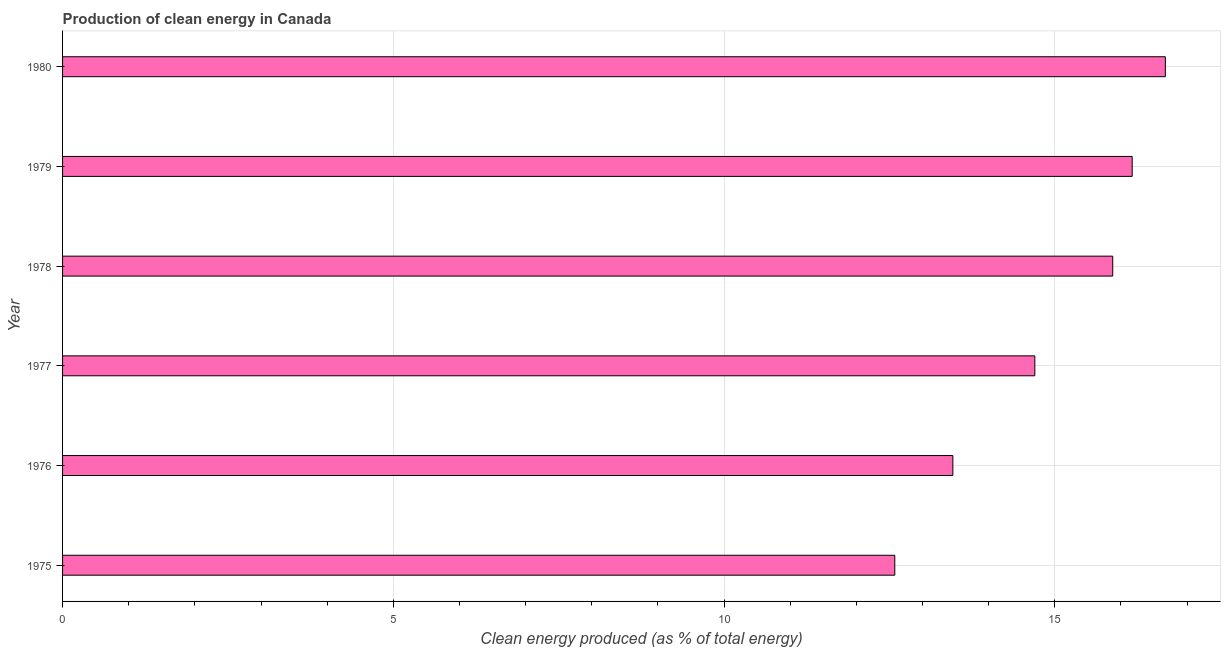Does the graph contain any zero values?
Make the answer very short. No. What is the title of the graph?
Give a very brief answer. Production of clean energy in Canada. What is the label or title of the X-axis?
Keep it short and to the point. Clean energy produced (as % of total energy). What is the production of clean energy in 1975?
Your response must be concise. 12.58. Across all years, what is the maximum production of clean energy?
Keep it short and to the point. 16.67. Across all years, what is the minimum production of clean energy?
Your answer should be compact. 12.58. In which year was the production of clean energy minimum?
Ensure brevity in your answer.  1975. What is the sum of the production of clean energy?
Keep it short and to the point. 89.46. What is the difference between the production of clean energy in 1977 and 1979?
Make the answer very short. -1.47. What is the average production of clean energy per year?
Keep it short and to the point. 14.91. What is the median production of clean energy?
Ensure brevity in your answer.  15.29. Do a majority of the years between 1977 and 1979 (inclusive) have production of clean energy greater than 1 %?
Ensure brevity in your answer.  Yes. What is the ratio of the production of clean energy in 1976 to that in 1980?
Provide a short and direct response. 0.81. Is the production of clean energy in 1975 less than that in 1976?
Offer a terse response. Yes. What is the difference between the highest and the second highest production of clean energy?
Give a very brief answer. 0.5. Is the sum of the production of clean energy in 1975 and 1976 greater than the maximum production of clean energy across all years?
Keep it short and to the point. Yes. What is the difference between the highest and the lowest production of clean energy?
Make the answer very short. 4.09. In how many years, is the production of clean energy greater than the average production of clean energy taken over all years?
Offer a very short reply. 3. How many bars are there?
Make the answer very short. 6. Are all the bars in the graph horizontal?
Give a very brief answer. Yes. How many years are there in the graph?
Your answer should be very brief. 6. What is the difference between two consecutive major ticks on the X-axis?
Give a very brief answer. 5. What is the Clean energy produced (as % of total energy) of 1975?
Offer a terse response. 12.58. What is the Clean energy produced (as % of total energy) of 1976?
Offer a very short reply. 13.46. What is the Clean energy produced (as % of total energy) in 1977?
Give a very brief answer. 14.7. What is the Clean energy produced (as % of total energy) in 1978?
Keep it short and to the point. 15.88. What is the Clean energy produced (as % of total energy) in 1979?
Ensure brevity in your answer.  16.17. What is the Clean energy produced (as % of total energy) of 1980?
Ensure brevity in your answer.  16.67. What is the difference between the Clean energy produced (as % of total energy) in 1975 and 1976?
Provide a short and direct response. -0.88. What is the difference between the Clean energy produced (as % of total energy) in 1975 and 1977?
Ensure brevity in your answer.  -2.12. What is the difference between the Clean energy produced (as % of total energy) in 1975 and 1978?
Your response must be concise. -3.29. What is the difference between the Clean energy produced (as % of total energy) in 1975 and 1979?
Give a very brief answer. -3.59. What is the difference between the Clean energy produced (as % of total energy) in 1975 and 1980?
Keep it short and to the point. -4.09. What is the difference between the Clean energy produced (as % of total energy) in 1976 and 1977?
Your answer should be very brief. -1.24. What is the difference between the Clean energy produced (as % of total energy) in 1976 and 1978?
Provide a short and direct response. -2.42. What is the difference between the Clean energy produced (as % of total energy) in 1976 and 1979?
Ensure brevity in your answer.  -2.71. What is the difference between the Clean energy produced (as % of total energy) in 1976 and 1980?
Your response must be concise. -3.21. What is the difference between the Clean energy produced (as % of total energy) in 1977 and 1978?
Your response must be concise. -1.18. What is the difference between the Clean energy produced (as % of total energy) in 1977 and 1979?
Offer a very short reply. -1.47. What is the difference between the Clean energy produced (as % of total energy) in 1977 and 1980?
Offer a terse response. -1.97. What is the difference between the Clean energy produced (as % of total energy) in 1978 and 1979?
Offer a terse response. -0.29. What is the difference between the Clean energy produced (as % of total energy) in 1978 and 1980?
Provide a short and direct response. -0.8. What is the difference between the Clean energy produced (as % of total energy) in 1979 and 1980?
Give a very brief answer. -0.5. What is the ratio of the Clean energy produced (as % of total energy) in 1975 to that in 1976?
Ensure brevity in your answer.  0.94. What is the ratio of the Clean energy produced (as % of total energy) in 1975 to that in 1977?
Give a very brief answer. 0.86. What is the ratio of the Clean energy produced (as % of total energy) in 1975 to that in 1978?
Provide a short and direct response. 0.79. What is the ratio of the Clean energy produced (as % of total energy) in 1975 to that in 1979?
Your answer should be very brief. 0.78. What is the ratio of the Clean energy produced (as % of total energy) in 1975 to that in 1980?
Your answer should be compact. 0.76. What is the ratio of the Clean energy produced (as % of total energy) in 1976 to that in 1977?
Give a very brief answer. 0.92. What is the ratio of the Clean energy produced (as % of total energy) in 1976 to that in 1978?
Provide a succinct answer. 0.85. What is the ratio of the Clean energy produced (as % of total energy) in 1976 to that in 1979?
Give a very brief answer. 0.83. What is the ratio of the Clean energy produced (as % of total energy) in 1976 to that in 1980?
Make the answer very short. 0.81. What is the ratio of the Clean energy produced (as % of total energy) in 1977 to that in 1978?
Offer a terse response. 0.93. What is the ratio of the Clean energy produced (as % of total energy) in 1977 to that in 1979?
Offer a very short reply. 0.91. What is the ratio of the Clean energy produced (as % of total energy) in 1977 to that in 1980?
Make the answer very short. 0.88. What is the ratio of the Clean energy produced (as % of total energy) in 1978 to that in 1979?
Your response must be concise. 0.98. 